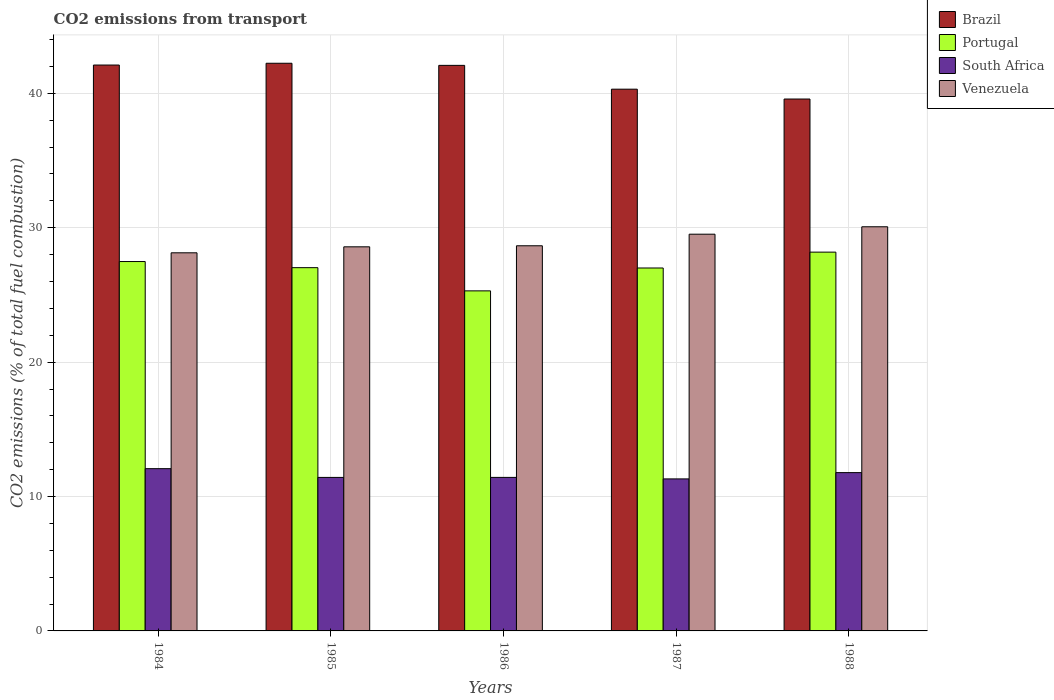How many different coloured bars are there?
Offer a terse response. 4. What is the label of the 1st group of bars from the left?
Provide a short and direct response. 1984. In how many cases, is the number of bars for a given year not equal to the number of legend labels?
Offer a terse response. 0. What is the total CO2 emitted in Portugal in 1984?
Offer a terse response. 27.48. Across all years, what is the maximum total CO2 emitted in Brazil?
Your response must be concise. 42.24. Across all years, what is the minimum total CO2 emitted in South Africa?
Ensure brevity in your answer.  11.31. In which year was the total CO2 emitted in South Africa maximum?
Provide a succinct answer. 1984. What is the total total CO2 emitted in South Africa in the graph?
Provide a succinct answer. 58.01. What is the difference between the total CO2 emitted in Brazil in 1985 and that in 1988?
Keep it short and to the point. 2.66. What is the difference between the total CO2 emitted in Venezuela in 1988 and the total CO2 emitted in Portugal in 1987?
Your response must be concise. 3.07. What is the average total CO2 emitted in Brazil per year?
Ensure brevity in your answer.  41.26. In the year 1988, what is the difference between the total CO2 emitted in Portugal and total CO2 emitted in Venezuela?
Your answer should be compact. -1.89. What is the ratio of the total CO2 emitted in Portugal in 1984 to that in 1988?
Ensure brevity in your answer.  0.98. Is the total CO2 emitted in Venezuela in 1986 less than that in 1988?
Provide a short and direct response. Yes. What is the difference between the highest and the second highest total CO2 emitted in Brazil?
Your response must be concise. 0.13. What is the difference between the highest and the lowest total CO2 emitted in Venezuela?
Ensure brevity in your answer.  1.94. Is the sum of the total CO2 emitted in Brazil in 1984 and 1986 greater than the maximum total CO2 emitted in Portugal across all years?
Offer a terse response. Yes. What does the 3rd bar from the left in 1984 represents?
Provide a succinct answer. South Africa. What does the 2nd bar from the right in 1988 represents?
Give a very brief answer. South Africa. Is it the case that in every year, the sum of the total CO2 emitted in Venezuela and total CO2 emitted in Brazil is greater than the total CO2 emitted in South Africa?
Your answer should be compact. Yes. How many bars are there?
Give a very brief answer. 20. Are all the bars in the graph horizontal?
Your answer should be very brief. No. How many years are there in the graph?
Your answer should be very brief. 5. Are the values on the major ticks of Y-axis written in scientific E-notation?
Ensure brevity in your answer.  No. Does the graph contain any zero values?
Ensure brevity in your answer.  No. How many legend labels are there?
Offer a very short reply. 4. What is the title of the graph?
Your response must be concise. CO2 emissions from transport. Does "Chile" appear as one of the legend labels in the graph?
Your response must be concise. No. What is the label or title of the X-axis?
Provide a short and direct response. Years. What is the label or title of the Y-axis?
Give a very brief answer. CO2 emissions (% of total fuel combustion). What is the CO2 emissions (% of total fuel combustion) in Brazil in 1984?
Your answer should be compact. 42.11. What is the CO2 emissions (% of total fuel combustion) of Portugal in 1984?
Your response must be concise. 27.48. What is the CO2 emissions (% of total fuel combustion) in South Africa in 1984?
Your answer should be compact. 12.07. What is the CO2 emissions (% of total fuel combustion) in Venezuela in 1984?
Your response must be concise. 28.13. What is the CO2 emissions (% of total fuel combustion) in Brazil in 1985?
Offer a terse response. 42.24. What is the CO2 emissions (% of total fuel combustion) in Portugal in 1985?
Provide a succinct answer. 27.03. What is the CO2 emissions (% of total fuel combustion) in South Africa in 1985?
Make the answer very short. 11.42. What is the CO2 emissions (% of total fuel combustion) of Venezuela in 1985?
Provide a succinct answer. 28.58. What is the CO2 emissions (% of total fuel combustion) of Brazil in 1986?
Keep it short and to the point. 42.08. What is the CO2 emissions (% of total fuel combustion) in Portugal in 1986?
Ensure brevity in your answer.  25.3. What is the CO2 emissions (% of total fuel combustion) of South Africa in 1986?
Your answer should be compact. 11.42. What is the CO2 emissions (% of total fuel combustion) in Venezuela in 1986?
Provide a short and direct response. 28.66. What is the CO2 emissions (% of total fuel combustion) in Brazil in 1987?
Ensure brevity in your answer.  40.31. What is the CO2 emissions (% of total fuel combustion) of Portugal in 1987?
Offer a very short reply. 27. What is the CO2 emissions (% of total fuel combustion) in South Africa in 1987?
Your answer should be compact. 11.31. What is the CO2 emissions (% of total fuel combustion) in Venezuela in 1987?
Give a very brief answer. 29.52. What is the CO2 emissions (% of total fuel combustion) in Brazil in 1988?
Your answer should be compact. 39.58. What is the CO2 emissions (% of total fuel combustion) in Portugal in 1988?
Make the answer very short. 28.18. What is the CO2 emissions (% of total fuel combustion) of South Africa in 1988?
Offer a terse response. 11.78. What is the CO2 emissions (% of total fuel combustion) in Venezuela in 1988?
Your response must be concise. 30.07. Across all years, what is the maximum CO2 emissions (% of total fuel combustion) of Brazil?
Offer a terse response. 42.24. Across all years, what is the maximum CO2 emissions (% of total fuel combustion) in Portugal?
Offer a very short reply. 28.18. Across all years, what is the maximum CO2 emissions (% of total fuel combustion) in South Africa?
Give a very brief answer. 12.07. Across all years, what is the maximum CO2 emissions (% of total fuel combustion) of Venezuela?
Provide a succinct answer. 30.07. Across all years, what is the minimum CO2 emissions (% of total fuel combustion) in Brazil?
Ensure brevity in your answer.  39.58. Across all years, what is the minimum CO2 emissions (% of total fuel combustion) of Portugal?
Give a very brief answer. 25.3. Across all years, what is the minimum CO2 emissions (% of total fuel combustion) of South Africa?
Provide a succinct answer. 11.31. Across all years, what is the minimum CO2 emissions (% of total fuel combustion) of Venezuela?
Your answer should be very brief. 28.13. What is the total CO2 emissions (% of total fuel combustion) in Brazil in the graph?
Your answer should be very brief. 206.31. What is the total CO2 emissions (% of total fuel combustion) in Portugal in the graph?
Keep it short and to the point. 135.01. What is the total CO2 emissions (% of total fuel combustion) in South Africa in the graph?
Offer a terse response. 58.01. What is the total CO2 emissions (% of total fuel combustion) of Venezuela in the graph?
Your answer should be very brief. 144.96. What is the difference between the CO2 emissions (% of total fuel combustion) in Brazil in 1984 and that in 1985?
Make the answer very short. -0.13. What is the difference between the CO2 emissions (% of total fuel combustion) in Portugal in 1984 and that in 1985?
Offer a very short reply. 0.46. What is the difference between the CO2 emissions (% of total fuel combustion) of South Africa in 1984 and that in 1985?
Give a very brief answer. 0.65. What is the difference between the CO2 emissions (% of total fuel combustion) in Venezuela in 1984 and that in 1985?
Provide a short and direct response. -0.45. What is the difference between the CO2 emissions (% of total fuel combustion) of Brazil in 1984 and that in 1986?
Make the answer very short. 0.02. What is the difference between the CO2 emissions (% of total fuel combustion) of Portugal in 1984 and that in 1986?
Give a very brief answer. 2.18. What is the difference between the CO2 emissions (% of total fuel combustion) in South Africa in 1984 and that in 1986?
Make the answer very short. 0.65. What is the difference between the CO2 emissions (% of total fuel combustion) of Venezuela in 1984 and that in 1986?
Keep it short and to the point. -0.52. What is the difference between the CO2 emissions (% of total fuel combustion) of Brazil in 1984 and that in 1987?
Give a very brief answer. 1.8. What is the difference between the CO2 emissions (% of total fuel combustion) in Portugal in 1984 and that in 1987?
Keep it short and to the point. 0.48. What is the difference between the CO2 emissions (% of total fuel combustion) in South Africa in 1984 and that in 1987?
Offer a terse response. 0.76. What is the difference between the CO2 emissions (% of total fuel combustion) in Venezuela in 1984 and that in 1987?
Offer a terse response. -1.38. What is the difference between the CO2 emissions (% of total fuel combustion) in Brazil in 1984 and that in 1988?
Your answer should be compact. 2.53. What is the difference between the CO2 emissions (% of total fuel combustion) in Portugal in 1984 and that in 1988?
Your answer should be compact. -0.7. What is the difference between the CO2 emissions (% of total fuel combustion) in South Africa in 1984 and that in 1988?
Give a very brief answer. 0.29. What is the difference between the CO2 emissions (% of total fuel combustion) in Venezuela in 1984 and that in 1988?
Keep it short and to the point. -1.94. What is the difference between the CO2 emissions (% of total fuel combustion) of Brazil in 1985 and that in 1986?
Provide a short and direct response. 0.16. What is the difference between the CO2 emissions (% of total fuel combustion) in Portugal in 1985 and that in 1986?
Offer a very short reply. 1.73. What is the difference between the CO2 emissions (% of total fuel combustion) in South Africa in 1985 and that in 1986?
Provide a succinct answer. -0. What is the difference between the CO2 emissions (% of total fuel combustion) in Venezuela in 1985 and that in 1986?
Give a very brief answer. -0.08. What is the difference between the CO2 emissions (% of total fuel combustion) of Brazil in 1985 and that in 1987?
Make the answer very short. 1.93. What is the difference between the CO2 emissions (% of total fuel combustion) in Portugal in 1985 and that in 1987?
Keep it short and to the point. 0.02. What is the difference between the CO2 emissions (% of total fuel combustion) of South Africa in 1985 and that in 1987?
Provide a succinct answer. 0.11. What is the difference between the CO2 emissions (% of total fuel combustion) of Venezuela in 1985 and that in 1987?
Ensure brevity in your answer.  -0.94. What is the difference between the CO2 emissions (% of total fuel combustion) in Brazil in 1985 and that in 1988?
Offer a terse response. 2.66. What is the difference between the CO2 emissions (% of total fuel combustion) in Portugal in 1985 and that in 1988?
Keep it short and to the point. -1.16. What is the difference between the CO2 emissions (% of total fuel combustion) in South Africa in 1985 and that in 1988?
Provide a short and direct response. -0.36. What is the difference between the CO2 emissions (% of total fuel combustion) in Venezuela in 1985 and that in 1988?
Ensure brevity in your answer.  -1.49. What is the difference between the CO2 emissions (% of total fuel combustion) of Brazil in 1986 and that in 1987?
Your answer should be very brief. 1.77. What is the difference between the CO2 emissions (% of total fuel combustion) in Portugal in 1986 and that in 1987?
Keep it short and to the point. -1.7. What is the difference between the CO2 emissions (% of total fuel combustion) in South Africa in 1986 and that in 1987?
Offer a very short reply. 0.11. What is the difference between the CO2 emissions (% of total fuel combustion) in Venezuela in 1986 and that in 1987?
Ensure brevity in your answer.  -0.86. What is the difference between the CO2 emissions (% of total fuel combustion) in Brazil in 1986 and that in 1988?
Provide a succinct answer. 2.5. What is the difference between the CO2 emissions (% of total fuel combustion) in Portugal in 1986 and that in 1988?
Your response must be concise. -2.88. What is the difference between the CO2 emissions (% of total fuel combustion) in South Africa in 1986 and that in 1988?
Offer a very short reply. -0.36. What is the difference between the CO2 emissions (% of total fuel combustion) of Venezuela in 1986 and that in 1988?
Give a very brief answer. -1.41. What is the difference between the CO2 emissions (% of total fuel combustion) of Brazil in 1987 and that in 1988?
Give a very brief answer. 0.73. What is the difference between the CO2 emissions (% of total fuel combustion) of Portugal in 1987 and that in 1988?
Offer a terse response. -1.18. What is the difference between the CO2 emissions (% of total fuel combustion) in South Africa in 1987 and that in 1988?
Offer a very short reply. -0.47. What is the difference between the CO2 emissions (% of total fuel combustion) of Venezuela in 1987 and that in 1988?
Your answer should be very brief. -0.55. What is the difference between the CO2 emissions (% of total fuel combustion) of Brazil in 1984 and the CO2 emissions (% of total fuel combustion) of Portugal in 1985?
Keep it short and to the point. 15.08. What is the difference between the CO2 emissions (% of total fuel combustion) in Brazil in 1984 and the CO2 emissions (% of total fuel combustion) in South Africa in 1985?
Your answer should be very brief. 30.68. What is the difference between the CO2 emissions (% of total fuel combustion) of Brazil in 1984 and the CO2 emissions (% of total fuel combustion) of Venezuela in 1985?
Offer a terse response. 13.53. What is the difference between the CO2 emissions (% of total fuel combustion) in Portugal in 1984 and the CO2 emissions (% of total fuel combustion) in South Africa in 1985?
Ensure brevity in your answer.  16.06. What is the difference between the CO2 emissions (% of total fuel combustion) in Portugal in 1984 and the CO2 emissions (% of total fuel combustion) in Venezuela in 1985?
Provide a short and direct response. -1.1. What is the difference between the CO2 emissions (% of total fuel combustion) of South Africa in 1984 and the CO2 emissions (% of total fuel combustion) of Venezuela in 1985?
Keep it short and to the point. -16.51. What is the difference between the CO2 emissions (% of total fuel combustion) of Brazil in 1984 and the CO2 emissions (% of total fuel combustion) of Portugal in 1986?
Provide a short and direct response. 16.8. What is the difference between the CO2 emissions (% of total fuel combustion) of Brazil in 1984 and the CO2 emissions (% of total fuel combustion) of South Africa in 1986?
Provide a short and direct response. 30.68. What is the difference between the CO2 emissions (% of total fuel combustion) of Brazil in 1984 and the CO2 emissions (% of total fuel combustion) of Venezuela in 1986?
Offer a very short reply. 13.45. What is the difference between the CO2 emissions (% of total fuel combustion) in Portugal in 1984 and the CO2 emissions (% of total fuel combustion) in South Africa in 1986?
Offer a very short reply. 16.06. What is the difference between the CO2 emissions (% of total fuel combustion) of Portugal in 1984 and the CO2 emissions (% of total fuel combustion) of Venezuela in 1986?
Give a very brief answer. -1.17. What is the difference between the CO2 emissions (% of total fuel combustion) in South Africa in 1984 and the CO2 emissions (% of total fuel combustion) in Venezuela in 1986?
Your response must be concise. -16.58. What is the difference between the CO2 emissions (% of total fuel combustion) in Brazil in 1984 and the CO2 emissions (% of total fuel combustion) in Portugal in 1987?
Keep it short and to the point. 15.1. What is the difference between the CO2 emissions (% of total fuel combustion) of Brazil in 1984 and the CO2 emissions (% of total fuel combustion) of South Africa in 1987?
Your answer should be compact. 30.79. What is the difference between the CO2 emissions (% of total fuel combustion) in Brazil in 1984 and the CO2 emissions (% of total fuel combustion) in Venezuela in 1987?
Offer a very short reply. 12.59. What is the difference between the CO2 emissions (% of total fuel combustion) in Portugal in 1984 and the CO2 emissions (% of total fuel combustion) in South Africa in 1987?
Provide a short and direct response. 16.17. What is the difference between the CO2 emissions (% of total fuel combustion) in Portugal in 1984 and the CO2 emissions (% of total fuel combustion) in Venezuela in 1987?
Give a very brief answer. -2.04. What is the difference between the CO2 emissions (% of total fuel combustion) in South Africa in 1984 and the CO2 emissions (% of total fuel combustion) in Venezuela in 1987?
Your answer should be very brief. -17.45. What is the difference between the CO2 emissions (% of total fuel combustion) of Brazil in 1984 and the CO2 emissions (% of total fuel combustion) of Portugal in 1988?
Keep it short and to the point. 13.92. What is the difference between the CO2 emissions (% of total fuel combustion) of Brazil in 1984 and the CO2 emissions (% of total fuel combustion) of South Africa in 1988?
Give a very brief answer. 30.33. What is the difference between the CO2 emissions (% of total fuel combustion) of Brazil in 1984 and the CO2 emissions (% of total fuel combustion) of Venezuela in 1988?
Give a very brief answer. 12.03. What is the difference between the CO2 emissions (% of total fuel combustion) of Portugal in 1984 and the CO2 emissions (% of total fuel combustion) of South Africa in 1988?
Provide a succinct answer. 15.71. What is the difference between the CO2 emissions (% of total fuel combustion) in Portugal in 1984 and the CO2 emissions (% of total fuel combustion) in Venezuela in 1988?
Your response must be concise. -2.59. What is the difference between the CO2 emissions (% of total fuel combustion) in South Africa in 1984 and the CO2 emissions (% of total fuel combustion) in Venezuela in 1988?
Ensure brevity in your answer.  -18. What is the difference between the CO2 emissions (% of total fuel combustion) of Brazil in 1985 and the CO2 emissions (% of total fuel combustion) of Portugal in 1986?
Keep it short and to the point. 16.94. What is the difference between the CO2 emissions (% of total fuel combustion) of Brazil in 1985 and the CO2 emissions (% of total fuel combustion) of South Africa in 1986?
Offer a very short reply. 30.82. What is the difference between the CO2 emissions (% of total fuel combustion) in Brazil in 1985 and the CO2 emissions (% of total fuel combustion) in Venezuela in 1986?
Keep it short and to the point. 13.58. What is the difference between the CO2 emissions (% of total fuel combustion) in Portugal in 1985 and the CO2 emissions (% of total fuel combustion) in South Africa in 1986?
Offer a terse response. 15.61. What is the difference between the CO2 emissions (% of total fuel combustion) of Portugal in 1985 and the CO2 emissions (% of total fuel combustion) of Venezuela in 1986?
Give a very brief answer. -1.63. What is the difference between the CO2 emissions (% of total fuel combustion) of South Africa in 1985 and the CO2 emissions (% of total fuel combustion) of Venezuela in 1986?
Ensure brevity in your answer.  -17.24. What is the difference between the CO2 emissions (% of total fuel combustion) in Brazil in 1985 and the CO2 emissions (% of total fuel combustion) in Portugal in 1987?
Offer a terse response. 15.23. What is the difference between the CO2 emissions (% of total fuel combustion) of Brazil in 1985 and the CO2 emissions (% of total fuel combustion) of South Africa in 1987?
Your response must be concise. 30.93. What is the difference between the CO2 emissions (% of total fuel combustion) in Brazil in 1985 and the CO2 emissions (% of total fuel combustion) in Venezuela in 1987?
Ensure brevity in your answer.  12.72. What is the difference between the CO2 emissions (% of total fuel combustion) of Portugal in 1985 and the CO2 emissions (% of total fuel combustion) of South Africa in 1987?
Offer a terse response. 15.72. What is the difference between the CO2 emissions (% of total fuel combustion) in Portugal in 1985 and the CO2 emissions (% of total fuel combustion) in Venezuela in 1987?
Your response must be concise. -2.49. What is the difference between the CO2 emissions (% of total fuel combustion) of South Africa in 1985 and the CO2 emissions (% of total fuel combustion) of Venezuela in 1987?
Provide a short and direct response. -18.1. What is the difference between the CO2 emissions (% of total fuel combustion) of Brazil in 1985 and the CO2 emissions (% of total fuel combustion) of Portugal in 1988?
Provide a succinct answer. 14.05. What is the difference between the CO2 emissions (% of total fuel combustion) in Brazil in 1985 and the CO2 emissions (% of total fuel combustion) in South Africa in 1988?
Offer a very short reply. 30.46. What is the difference between the CO2 emissions (% of total fuel combustion) of Brazil in 1985 and the CO2 emissions (% of total fuel combustion) of Venezuela in 1988?
Your answer should be compact. 12.17. What is the difference between the CO2 emissions (% of total fuel combustion) in Portugal in 1985 and the CO2 emissions (% of total fuel combustion) in South Africa in 1988?
Keep it short and to the point. 15.25. What is the difference between the CO2 emissions (% of total fuel combustion) in Portugal in 1985 and the CO2 emissions (% of total fuel combustion) in Venezuela in 1988?
Your answer should be compact. -3.04. What is the difference between the CO2 emissions (% of total fuel combustion) of South Africa in 1985 and the CO2 emissions (% of total fuel combustion) of Venezuela in 1988?
Offer a very short reply. -18.65. What is the difference between the CO2 emissions (% of total fuel combustion) of Brazil in 1986 and the CO2 emissions (% of total fuel combustion) of Portugal in 1987?
Offer a very short reply. 15.08. What is the difference between the CO2 emissions (% of total fuel combustion) in Brazil in 1986 and the CO2 emissions (% of total fuel combustion) in South Africa in 1987?
Your answer should be compact. 30.77. What is the difference between the CO2 emissions (% of total fuel combustion) of Brazil in 1986 and the CO2 emissions (% of total fuel combustion) of Venezuela in 1987?
Your answer should be very brief. 12.56. What is the difference between the CO2 emissions (% of total fuel combustion) in Portugal in 1986 and the CO2 emissions (% of total fuel combustion) in South Africa in 1987?
Your answer should be very brief. 13.99. What is the difference between the CO2 emissions (% of total fuel combustion) in Portugal in 1986 and the CO2 emissions (% of total fuel combustion) in Venezuela in 1987?
Your response must be concise. -4.22. What is the difference between the CO2 emissions (% of total fuel combustion) in South Africa in 1986 and the CO2 emissions (% of total fuel combustion) in Venezuela in 1987?
Ensure brevity in your answer.  -18.1. What is the difference between the CO2 emissions (% of total fuel combustion) in Brazil in 1986 and the CO2 emissions (% of total fuel combustion) in Portugal in 1988?
Your answer should be very brief. 13.9. What is the difference between the CO2 emissions (% of total fuel combustion) of Brazil in 1986 and the CO2 emissions (% of total fuel combustion) of South Africa in 1988?
Make the answer very short. 30.3. What is the difference between the CO2 emissions (% of total fuel combustion) of Brazil in 1986 and the CO2 emissions (% of total fuel combustion) of Venezuela in 1988?
Provide a succinct answer. 12.01. What is the difference between the CO2 emissions (% of total fuel combustion) in Portugal in 1986 and the CO2 emissions (% of total fuel combustion) in South Africa in 1988?
Give a very brief answer. 13.52. What is the difference between the CO2 emissions (% of total fuel combustion) in Portugal in 1986 and the CO2 emissions (% of total fuel combustion) in Venezuela in 1988?
Keep it short and to the point. -4.77. What is the difference between the CO2 emissions (% of total fuel combustion) in South Africa in 1986 and the CO2 emissions (% of total fuel combustion) in Venezuela in 1988?
Your answer should be very brief. -18.65. What is the difference between the CO2 emissions (% of total fuel combustion) in Brazil in 1987 and the CO2 emissions (% of total fuel combustion) in Portugal in 1988?
Provide a succinct answer. 12.13. What is the difference between the CO2 emissions (% of total fuel combustion) in Brazil in 1987 and the CO2 emissions (% of total fuel combustion) in South Africa in 1988?
Give a very brief answer. 28.53. What is the difference between the CO2 emissions (% of total fuel combustion) in Brazil in 1987 and the CO2 emissions (% of total fuel combustion) in Venezuela in 1988?
Ensure brevity in your answer.  10.24. What is the difference between the CO2 emissions (% of total fuel combustion) of Portugal in 1987 and the CO2 emissions (% of total fuel combustion) of South Africa in 1988?
Provide a succinct answer. 15.23. What is the difference between the CO2 emissions (% of total fuel combustion) of Portugal in 1987 and the CO2 emissions (% of total fuel combustion) of Venezuela in 1988?
Provide a succinct answer. -3.07. What is the difference between the CO2 emissions (% of total fuel combustion) of South Africa in 1987 and the CO2 emissions (% of total fuel combustion) of Venezuela in 1988?
Your answer should be compact. -18.76. What is the average CO2 emissions (% of total fuel combustion) of Brazil per year?
Offer a very short reply. 41.26. What is the average CO2 emissions (% of total fuel combustion) of Portugal per year?
Offer a terse response. 27. What is the average CO2 emissions (% of total fuel combustion) of South Africa per year?
Provide a short and direct response. 11.6. What is the average CO2 emissions (% of total fuel combustion) in Venezuela per year?
Your response must be concise. 28.99. In the year 1984, what is the difference between the CO2 emissions (% of total fuel combustion) of Brazil and CO2 emissions (% of total fuel combustion) of Portugal?
Make the answer very short. 14.62. In the year 1984, what is the difference between the CO2 emissions (% of total fuel combustion) in Brazil and CO2 emissions (% of total fuel combustion) in South Africa?
Offer a very short reply. 30.03. In the year 1984, what is the difference between the CO2 emissions (% of total fuel combustion) in Brazil and CO2 emissions (% of total fuel combustion) in Venezuela?
Ensure brevity in your answer.  13.97. In the year 1984, what is the difference between the CO2 emissions (% of total fuel combustion) in Portugal and CO2 emissions (% of total fuel combustion) in South Africa?
Keep it short and to the point. 15.41. In the year 1984, what is the difference between the CO2 emissions (% of total fuel combustion) in Portugal and CO2 emissions (% of total fuel combustion) in Venezuela?
Make the answer very short. -0.65. In the year 1984, what is the difference between the CO2 emissions (% of total fuel combustion) of South Africa and CO2 emissions (% of total fuel combustion) of Venezuela?
Your response must be concise. -16.06. In the year 1985, what is the difference between the CO2 emissions (% of total fuel combustion) in Brazil and CO2 emissions (% of total fuel combustion) in Portugal?
Your answer should be very brief. 15.21. In the year 1985, what is the difference between the CO2 emissions (% of total fuel combustion) of Brazil and CO2 emissions (% of total fuel combustion) of South Africa?
Your answer should be compact. 30.82. In the year 1985, what is the difference between the CO2 emissions (% of total fuel combustion) in Brazil and CO2 emissions (% of total fuel combustion) in Venezuela?
Give a very brief answer. 13.66. In the year 1985, what is the difference between the CO2 emissions (% of total fuel combustion) in Portugal and CO2 emissions (% of total fuel combustion) in South Africa?
Your answer should be very brief. 15.61. In the year 1985, what is the difference between the CO2 emissions (% of total fuel combustion) in Portugal and CO2 emissions (% of total fuel combustion) in Venezuela?
Offer a terse response. -1.55. In the year 1985, what is the difference between the CO2 emissions (% of total fuel combustion) in South Africa and CO2 emissions (% of total fuel combustion) in Venezuela?
Offer a very short reply. -17.16. In the year 1986, what is the difference between the CO2 emissions (% of total fuel combustion) of Brazil and CO2 emissions (% of total fuel combustion) of Portugal?
Your answer should be very brief. 16.78. In the year 1986, what is the difference between the CO2 emissions (% of total fuel combustion) of Brazil and CO2 emissions (% of total fuel combustion) of South Africa?
Offer a very short reply. 30.66. In the year 1986, what is the difference between the CO2 emissions (% of total fuel combustion) of Brazil and CO2 emissions (% of total fuel combustion) of Venezuela?
Ensure brevity in your answer.  13.42. In the year 1986, what is the difference between the CO2 emissions (% of total fuel combustion) of Portugal and CO2 emissions (% of total fuel combustion) of South Africa?
Your response must be concise. 13.88. In the year 1986, what is the difference between the CO2 emissions (% of total fuel combustion) in Portugal and CO2 emissions (% of total fuel combustion) in Venezuela?
Your response must be concise. -3.36. In the year 1986, what is the difference between the CO2 emissions (% of total fuel combustion) in South Africa and CO2 emissions (% of total fuel combustion) in Venezuela?
Your answer should be compact. -17.24. In the year 1987, what is the difference between the CO2 emissions (% of total fuel combustion) of Brazil and CO2 emissions (% of total fuel combustion) of Portugal?
Your answer should be very brief. 13.31. In the year 1987, what is the difference between the CO2 emissions (% of total fuel combustion) in Brazil and CO2 emissions (% of total fuel combustion) in South Africa?
Provide a succinct answer. 29. In the year 1987, what is the difference between the CO2 emissions (% of total fuel combustion) in Brazil and CO2 emissions (% of total fuel combustion) in Venezuela?
Your answer should be compact. 10.79. In the year 1987, what is the difference between the CO2 emissions (% of total fuel combustion) in Portugal and CO2 emissions (% of total fuel combustion) in South Africa?
Keep it short and to the point. 15.69. In the year 1987, what is the difference between the CO2 emissions (% of total fuel combustion) of Portugal and CO2 emissions (% of total fuel combustion) of Venezuela?
Ensure brevity in your answer.  -2.52. In the year 1987, what is the difference between the CO2 emissions (% of total fuel combustion) in South Africa and CO2 emissions (% of total fuel combustion) in Venezuela?
Offer a terse response. -18.21. In the year 1988, what is the difference between the CO2 emissions (% of total fuel combustion) in Brazil and CO2 emissions (% of total fuel combustion) in Portugal?
Give a very brief answer. 11.39. In the year 1988, what is the difference between the CO2 emissions (% of total fuel combustion) in Brazil and CO2 emissions (% of total fuel combustion) in South Africa?
Your answer should be very brief. 27.8. In the year 1988, what is the difference between the CO2 emissions (% of total fuel combustion) in Brazil and CO2 emissions (% of total fuel combustion) in Venezuela?
Offer a very short reply. 9.51. In the year 1988, what is the difference between the CO2 emissions (% of total fuel combustion) of Portugal and CO2 emissions (% of total fuel combustion) of South Africa?
Your response must be concise. 16.41. In the year 1988, what is the difference between the CO2 emissions (% of total fuel combustion) in Portugal and CO2 emissions (% of total fuel combustion) in Venezuela?
Give a very brief answer. -1.89. In the year 1988, what is the difference between the CO2 emissions (% of total fuel combustion) in South Africa and CO2 emissions (% of total fuel combustion) in Venezuela?
Your answer should be very brief. -18.29. What is the ratio of the CO2 emissions (% of total fuel combustion) in Brazil in 1984 to that in 1985?
Provide a succinct answer. 1. What is the ratio of the CO2 emissions (% of total fuel combustion) in Portugal in 1984 to that in 1985?
Provide a short and direct response. 1.02. What is the ratio of the CO2 emissions (% of total fuel combustion) of South Africa in 1984 to that in 1985?
Make the answer very short. 1.06. What is the ratio of the CO2 emissions (% of total fuel combustion) of Venezuela in 1984 to that in 1985?
Offer a very short reply. 0.98. What is the ratio of the CO2 emissions (% of total fuel combustion) in Brazil in 1984 to that in 1986?
Provide a succinct answer. 1. What is the ratio of the CO2 emissions (% of total fuel combustion) in Portugal in 1984 to that in 1986?
Your response must be concise. 1.09. What is the ratio of the CO2 emissions (% of total fuel combustion) of South Africa in 1984 to that in 1986?
Offer a very short reply. 1.06. What is the ratio of the CO2 emissions (% of total fuel combustion) of Venezuela in 1984 to that in 1986?
Offer a terse response. 0.98. What is the ratio of the CO2 emissions (% of total fuel combustion) of Brazil in 1984 to that in 1987?
Your response must be concise. 1.04. What is the ratio of the CO2 emissions (% of total fuel combustion) in Portugal in 1984 to that in 1987?
Your answer should be very brief. 1.02. What is the ratio of the CO2 emissions (% of total fuel combustion) of South Africa in 1984 to that in 1987?
Provide a succinct answer. 1.07. What is the ratio of the CO2 emissions (% of total fuel combustion) of Venezuela in 1984 to that in 1987?
Your answer should be compact. 0.95. What is the ratio of the CO2 emissions (% of total fuel combustion) in Brazil in 1984 to that in 1988?
Your response must be concise. 1.06. What is the ratio of the CO2 emissions (% of total fuel combustion) in Portugal in 1984 to that in 1988?
Your answer should be very brief. 0.98. What is the ratio of the CO2 emissions (% of total fuel combustion) in South Africa in 1984 to that in 1988?
Offer a terse response. 1.02. What is the ratio of the CO2 emissions (% of total fuel combustion) of Venezuela in 1984 to that in 1988?
Offer a terse response. 0.94. What is the ratio of the CO2 emissions (% of total fuel combustion) of Portugal in 1985 to that in 1986?
Offer a terse response. 1.07. What is the ratio of the CO2 emissions (% of total fuel combustion) of South Africa in 1985 to that in 1986?
Keep it short and to the point. 1. What is the ratio of the CO2 emissions (% of total fuel combustion) in Brazil in 1985 to that in 1987?
Make the answer very short. 1.05. What is the ratio of the CO2 emissions (% of total fuel combustion) of South Africa in 1985 to that in 1987?
Provide a short and direct response. 1.01. What is the ratio of the CO2 emissions (% of total fuel combustion) in Venezuela in 1985 to that in 1987?
Your answer should be compact. 0.97. What is the ratio of the CO2 emissions (% of total fuel combustion) of Brazil in 1985 to that in 1988?
Give a very brief answer. 1.07. What is the ratio of the CO2 emissions (% of total fuel combustion) of South Africa in 1985 to that in 1988?
Your response must be concise. 0.97. What is the ratio of the CO2 emissions (% of total fuel combustion) of Venezuela in 1985 to that in 1988?
Make the answer very short. 0.95. What is the ratio of the CO2 emissions (% of total fuel combustion) of Brazil in 1986 to that in 1987?
Offer a very short reply. 1.04. What is the ratio of the CO2 emissions (% of total fuel combustion) in Portugal in 1986 to that in 1987?
Offer a very short reply. 0.94. What is the ratio of the CO2 emissions (% of total fuel combustion) of South Africa in 1986 to that in 1987?
Offer a terse response. 1.01. What is the ratio of the CO2 emissions (% of total fuel combustion) of Venezuela in 1986 to that in 1987?
Provide a short and direct response. 0.97. What is the ratio of the CO2 emissions (% of total fuel combustion) in Brazil in 1986 to that in 1988?
Provide a short and direct response. 1.06. What is the ratio of the CO2 emissions (% of total fuel combustion) of Portugal in 1986 to that in 1988?
Give a very brief answer. 0.9. What is the ratio of the CO2 emissions (% of total fuel combustion) of South Africa in 1986 to that in 1988?
Offer a terse response. 0.97. What is the ratio of the CO2 emissions (% of total fuel combustion) in Venezuela in 1986 to that in 1988?
Offer a very short reply. 0.95. What is the ratio of the CO2 emissions (% of total fuel combustion) of Brazil in 1987 to that in 1988?
Your response must be concise. 1.02. What is the ratio of the CO2 emissions (% of total fuel combustion) of Portugal in 1987 to that in 1988?
Provide a short and direct response. 0.96. What is the ratio of the CO2 emissions (% of total fuel combustion) in South Africa in 1987 to that in 1988?
Ensure brevity in your answer.  0.96. What is the ratio of the CO2 emissions (% of total fuel combustion) of Venezuela in 1987 to that in 1988?
Ensure brevity in your answer.  0.98. What is the difference between the highest and the second highest CO2 emissions (% of total fuel combustion) of Brazil?
Your answer should be compact. 0.13. What is the difference between the highest and the second highest CO2 emissions (% of total fuel combustion) of Portugal?
Ensure brevity in your answer.  0.7. What is the difference between the highest and the second highest CO2 emissions (% of total fuel combustion) in South Africa?
Offer a very short reply. 0.29. What is the difference between the highest and the second highest CO2 emissions (% of total fuel combustion) of Venezuela?
Make the answer very short. 0.55. What is the difference between the highest and the lowest CO2 emissions (% of total fuel combustion) in Brazil?
Keep it short and to the point. 2.66. What is the difference between the highest and the lowest CO2 emissions (% of total fuel combustion) of Portugal?
Offer a very short reply. 2.88. What is the difference between the highest and the lowest CO2 emissions (% of total fuel combustion) of South Africa?
Offer a very short reply. 0.76. What is the difference between the highest and the lowest CO2 emissions (% of total fuel combustion) in Venezuela?
Make the answer very short. 1.94. 